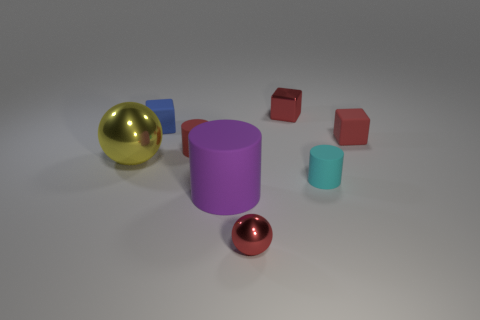Add 1 big blue matte blocks. How many objects exist? 9 Subtract all red blocks. How many blocks are left? 1 Subtract all yellow cylinders. How many red cubes are left? 2 Subtract all red cylinders. How many cylinders are left? 2 Subtract all cylinders. How many objects are left? 5 Subtract all small red matte cubes. Subtract all large yellow shiny objects. How many objects are left? 6 Add 2 tiny cyan matte cylinders. How many tiny cyan matte cylinders are left? 3 Add 7 large yellow cylinders. How many large yellow cylinders exist? 7 Subtract 0 cyan spheres. How many objects are left? 8 Subtract 3 blocks. How many blocks are left? 0 